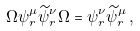<formula> <loc_0><loc_0><loc_500><loc_500>\Omega \psi _ { r } ^ { \mu } \widetilde { \psi } _ { r } ^ { \nu } \Omega = \psi _ { r } ^ { \nu } \widetilde { \psi } _ { r } ^ { \mu } \, ,</formula> 